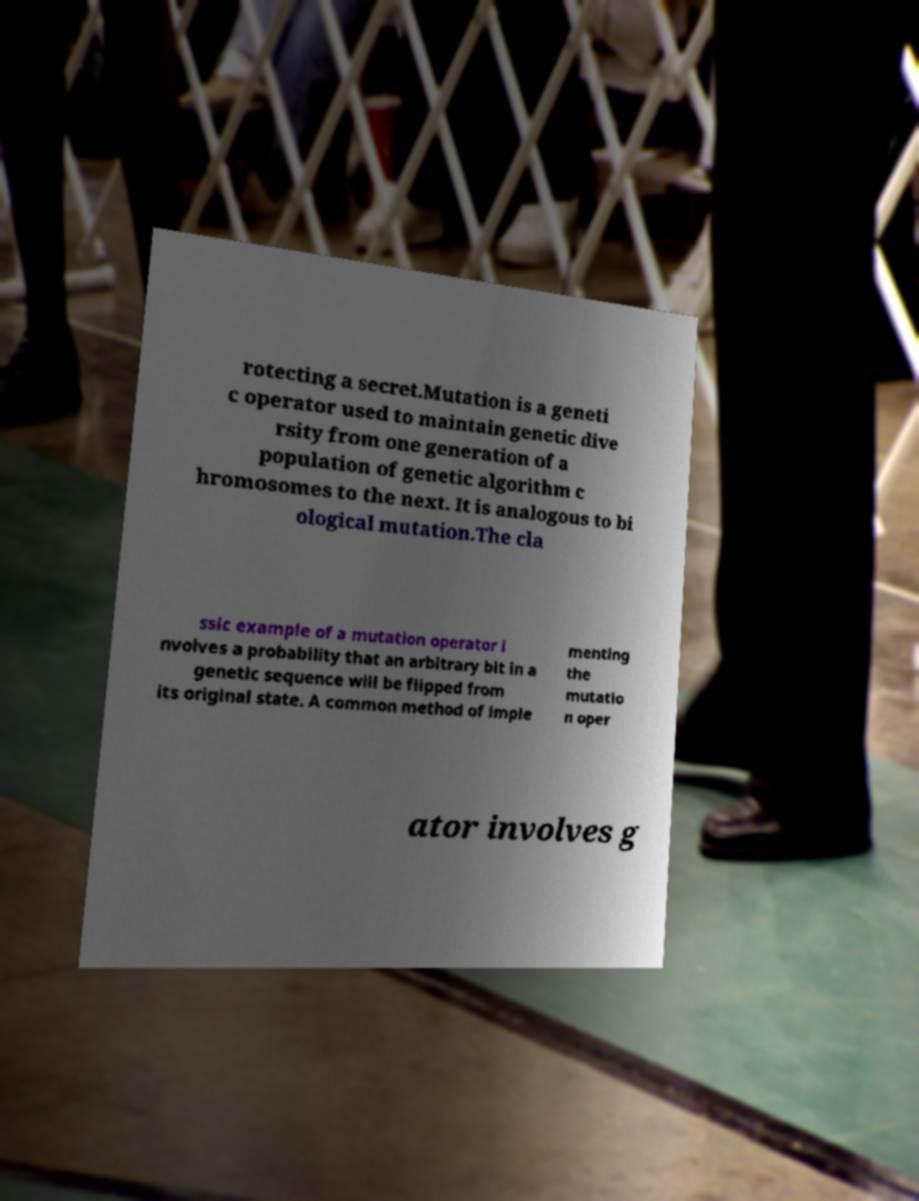For documentation purposes, I need the text within this image transcribed. Could you provide that? rotecting a secret.Mutation is a geneti c operator used to maintain genetic dive rsity from one generation of a population of genetic algorithm c hromosomes to the next. It is analogous to bi ological mutation.The cla ssic example of a mutation operator i nvolves a probability that an arbitrary bit in a genetic sequence will be flipped from its original state. A common method of imple menting the mutatio n oper ator involves g 